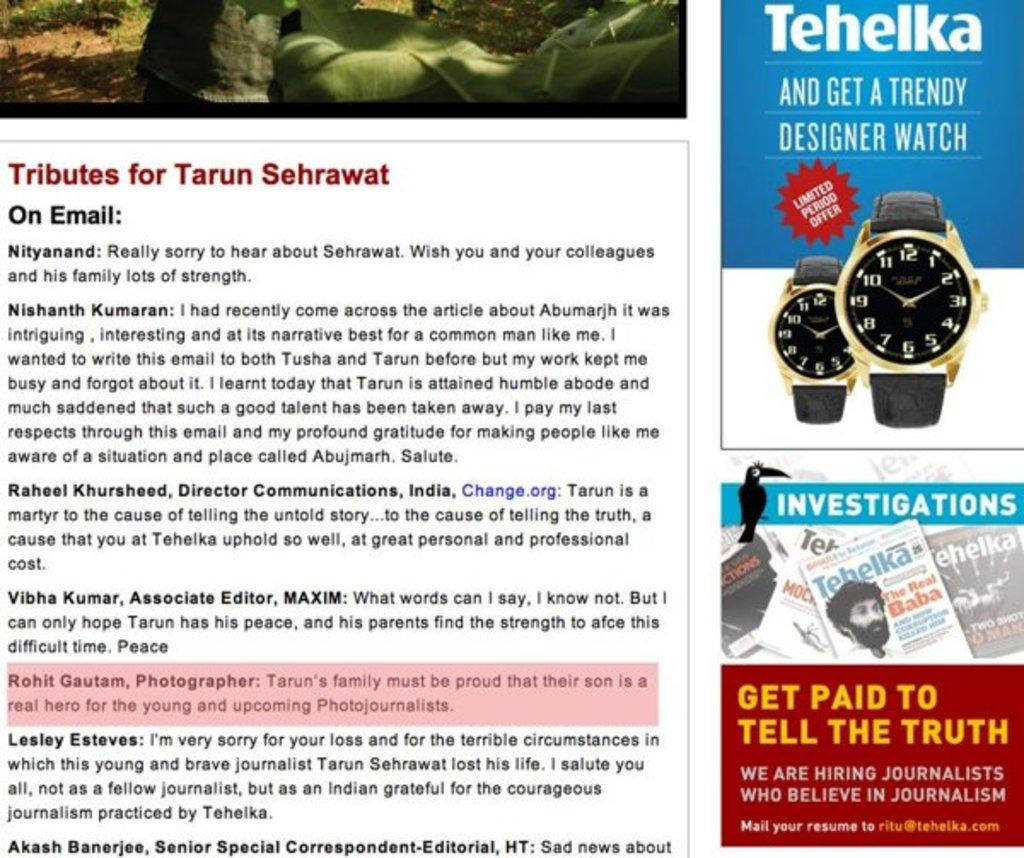<image>
Provide a brief description of the given image. An advertisement for a watch made by the bran Tehelka. 